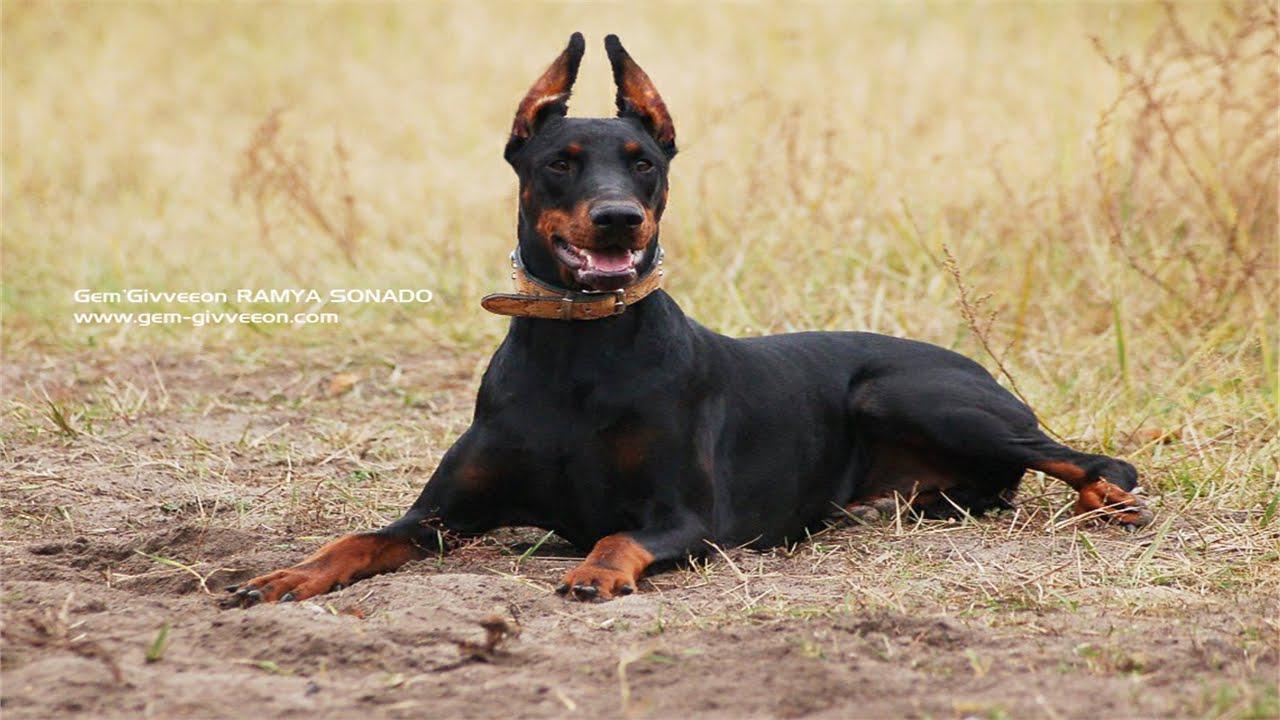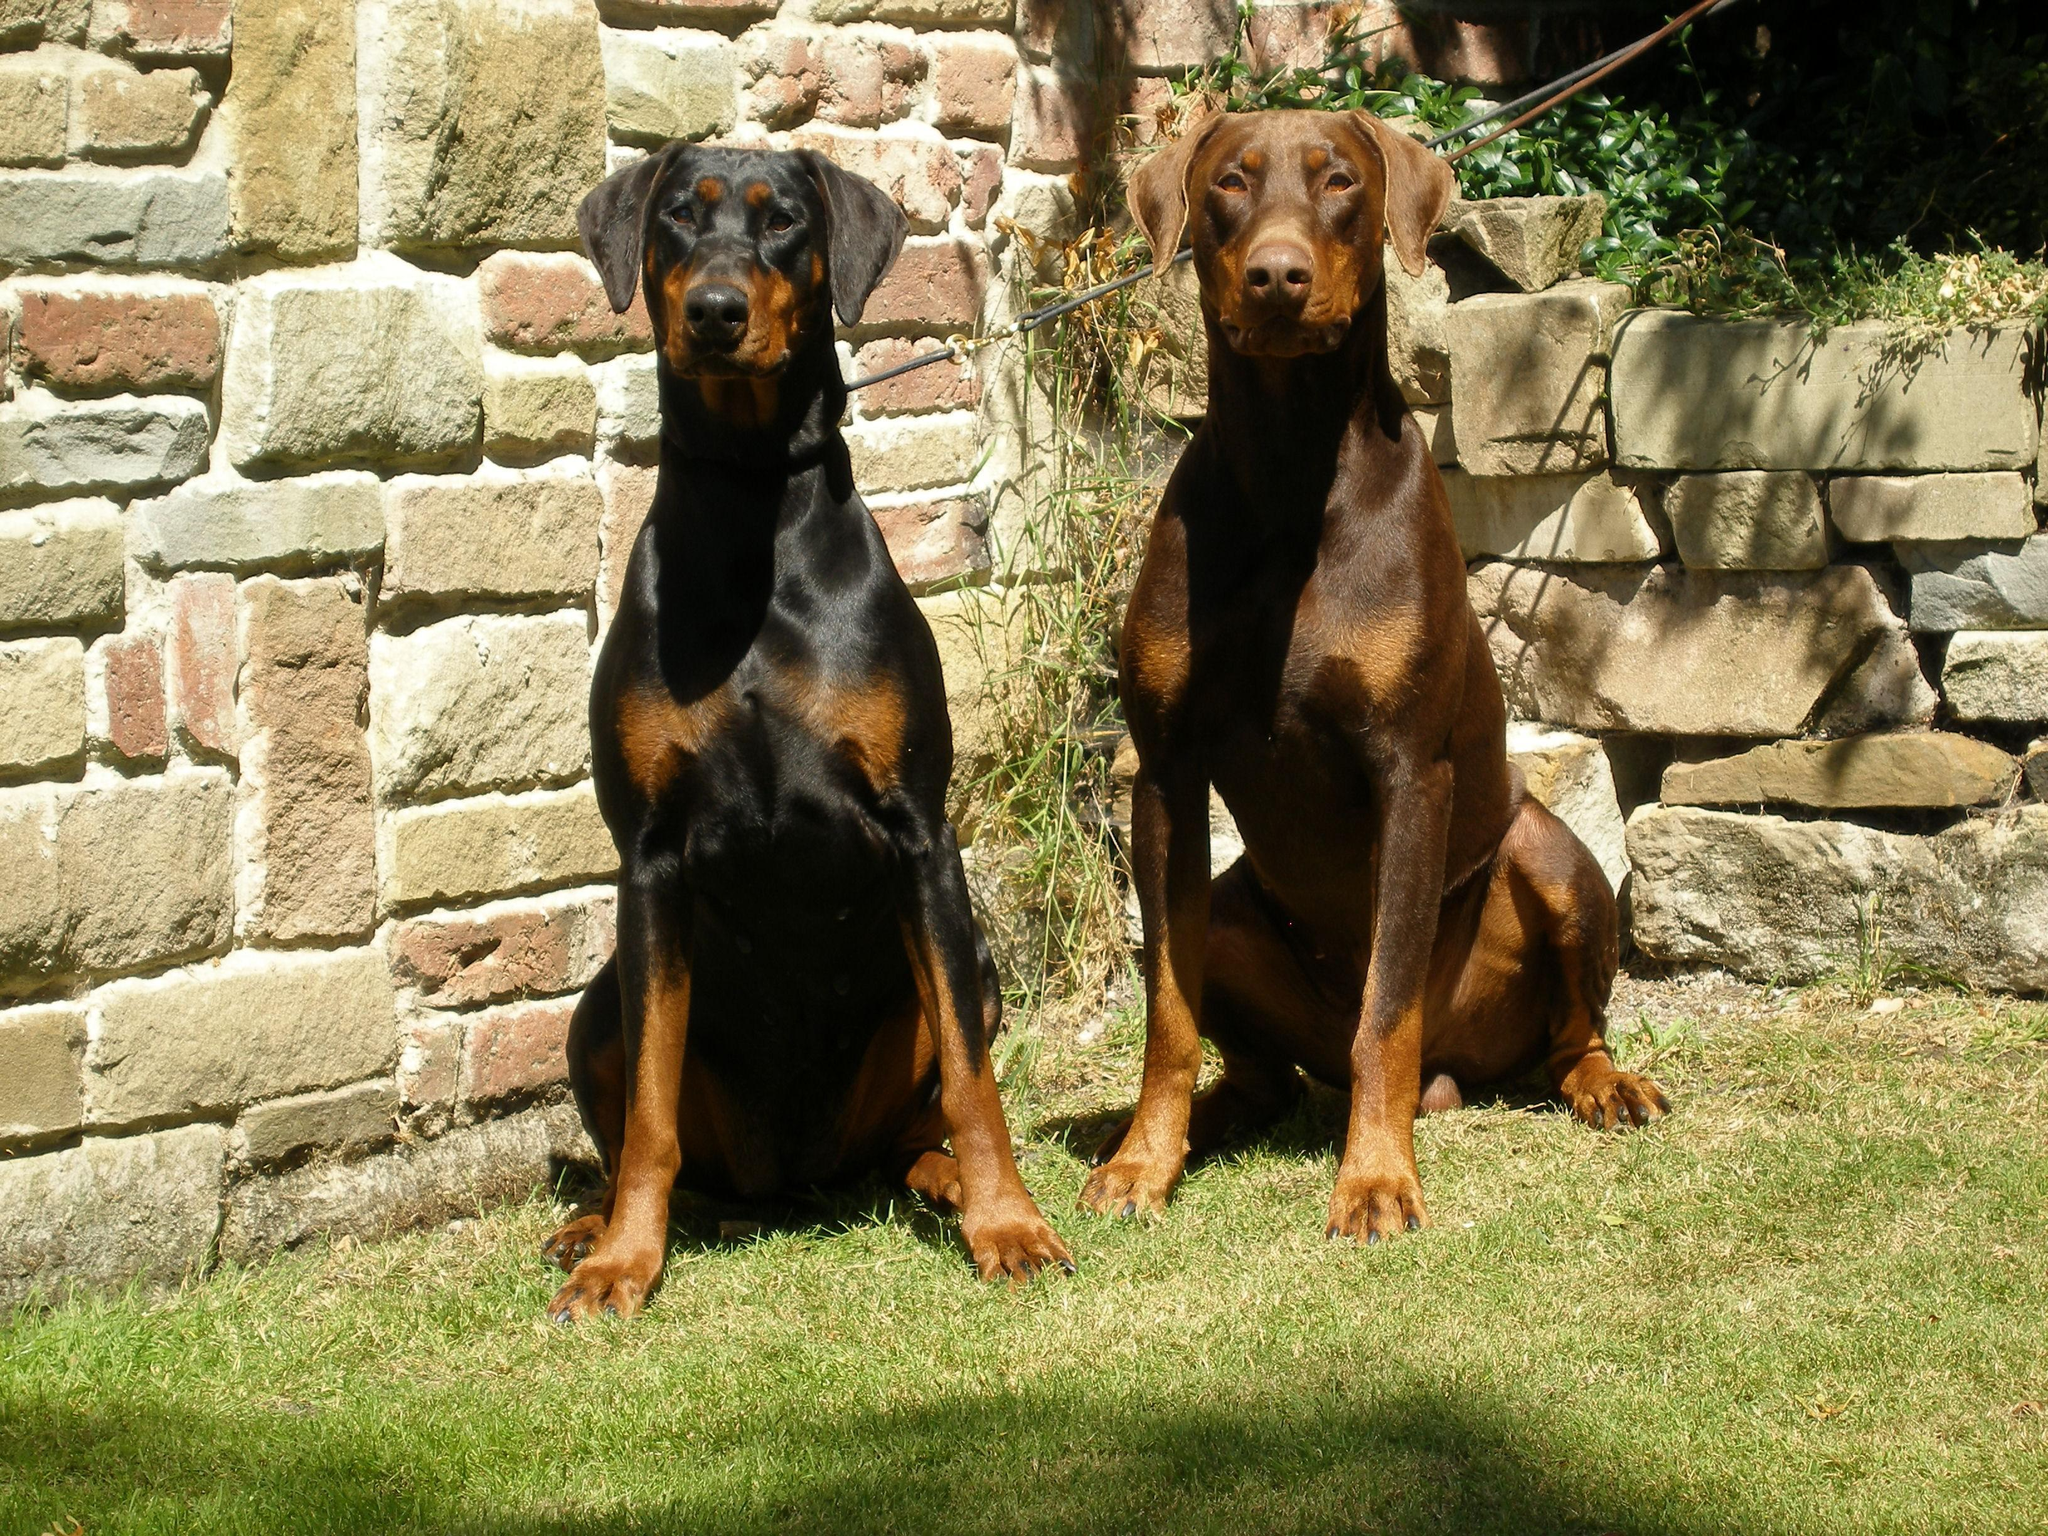The first image is the image on the left, the second image is the image on the right. Given the left and right images, does the statement "A minimum of 3 dogs are present" hold true? Answer yes or no. Yes. The first image is the image on the left, the second image is the image on the right. For the images displayed, is the sentence "The right image contains exactly two dogs." factually correct? Answer yes or no. Yes. 